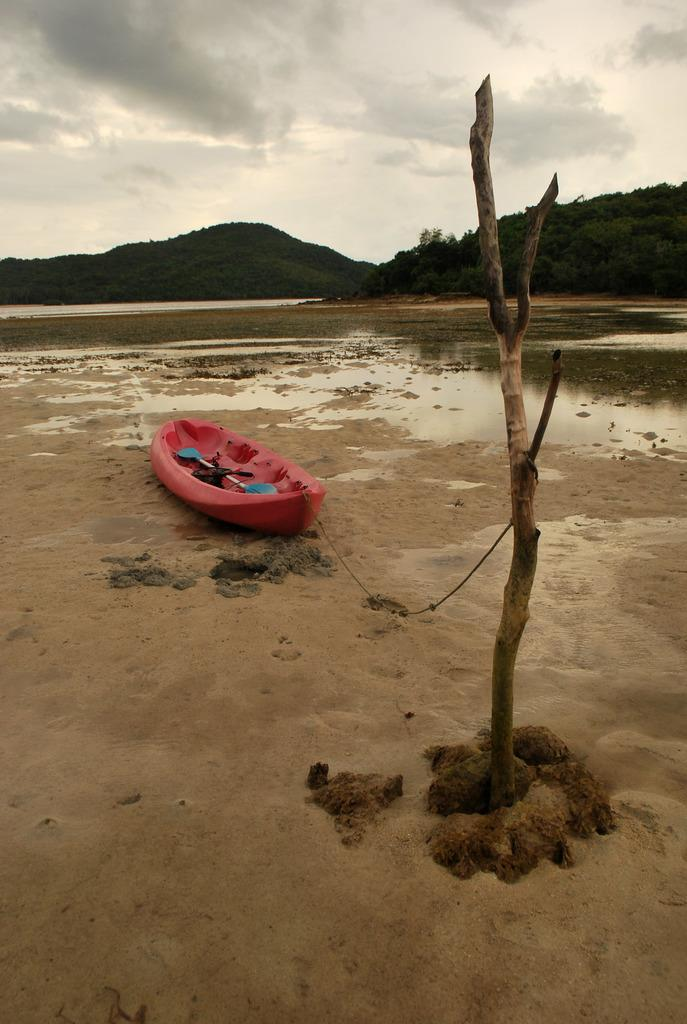What can be seen in the sky in the image? The sky is visible in the image. What type of landform is present in the image? There is a hill in the image. What body of water is present in the image? There is a water lake in the image. What is the color of the boat on the lake? A pink color boat is visible on the lake in the middle. What is the truck carrying in the image? There is a truck of tree in the image. What type of apparel are the sisters wearing in the image? There are no sisters or apparel present in the image. What type of ship can be seen sailing on the lake in the image? There is no ship present in the image; only a pink boat is visible on the lake. 